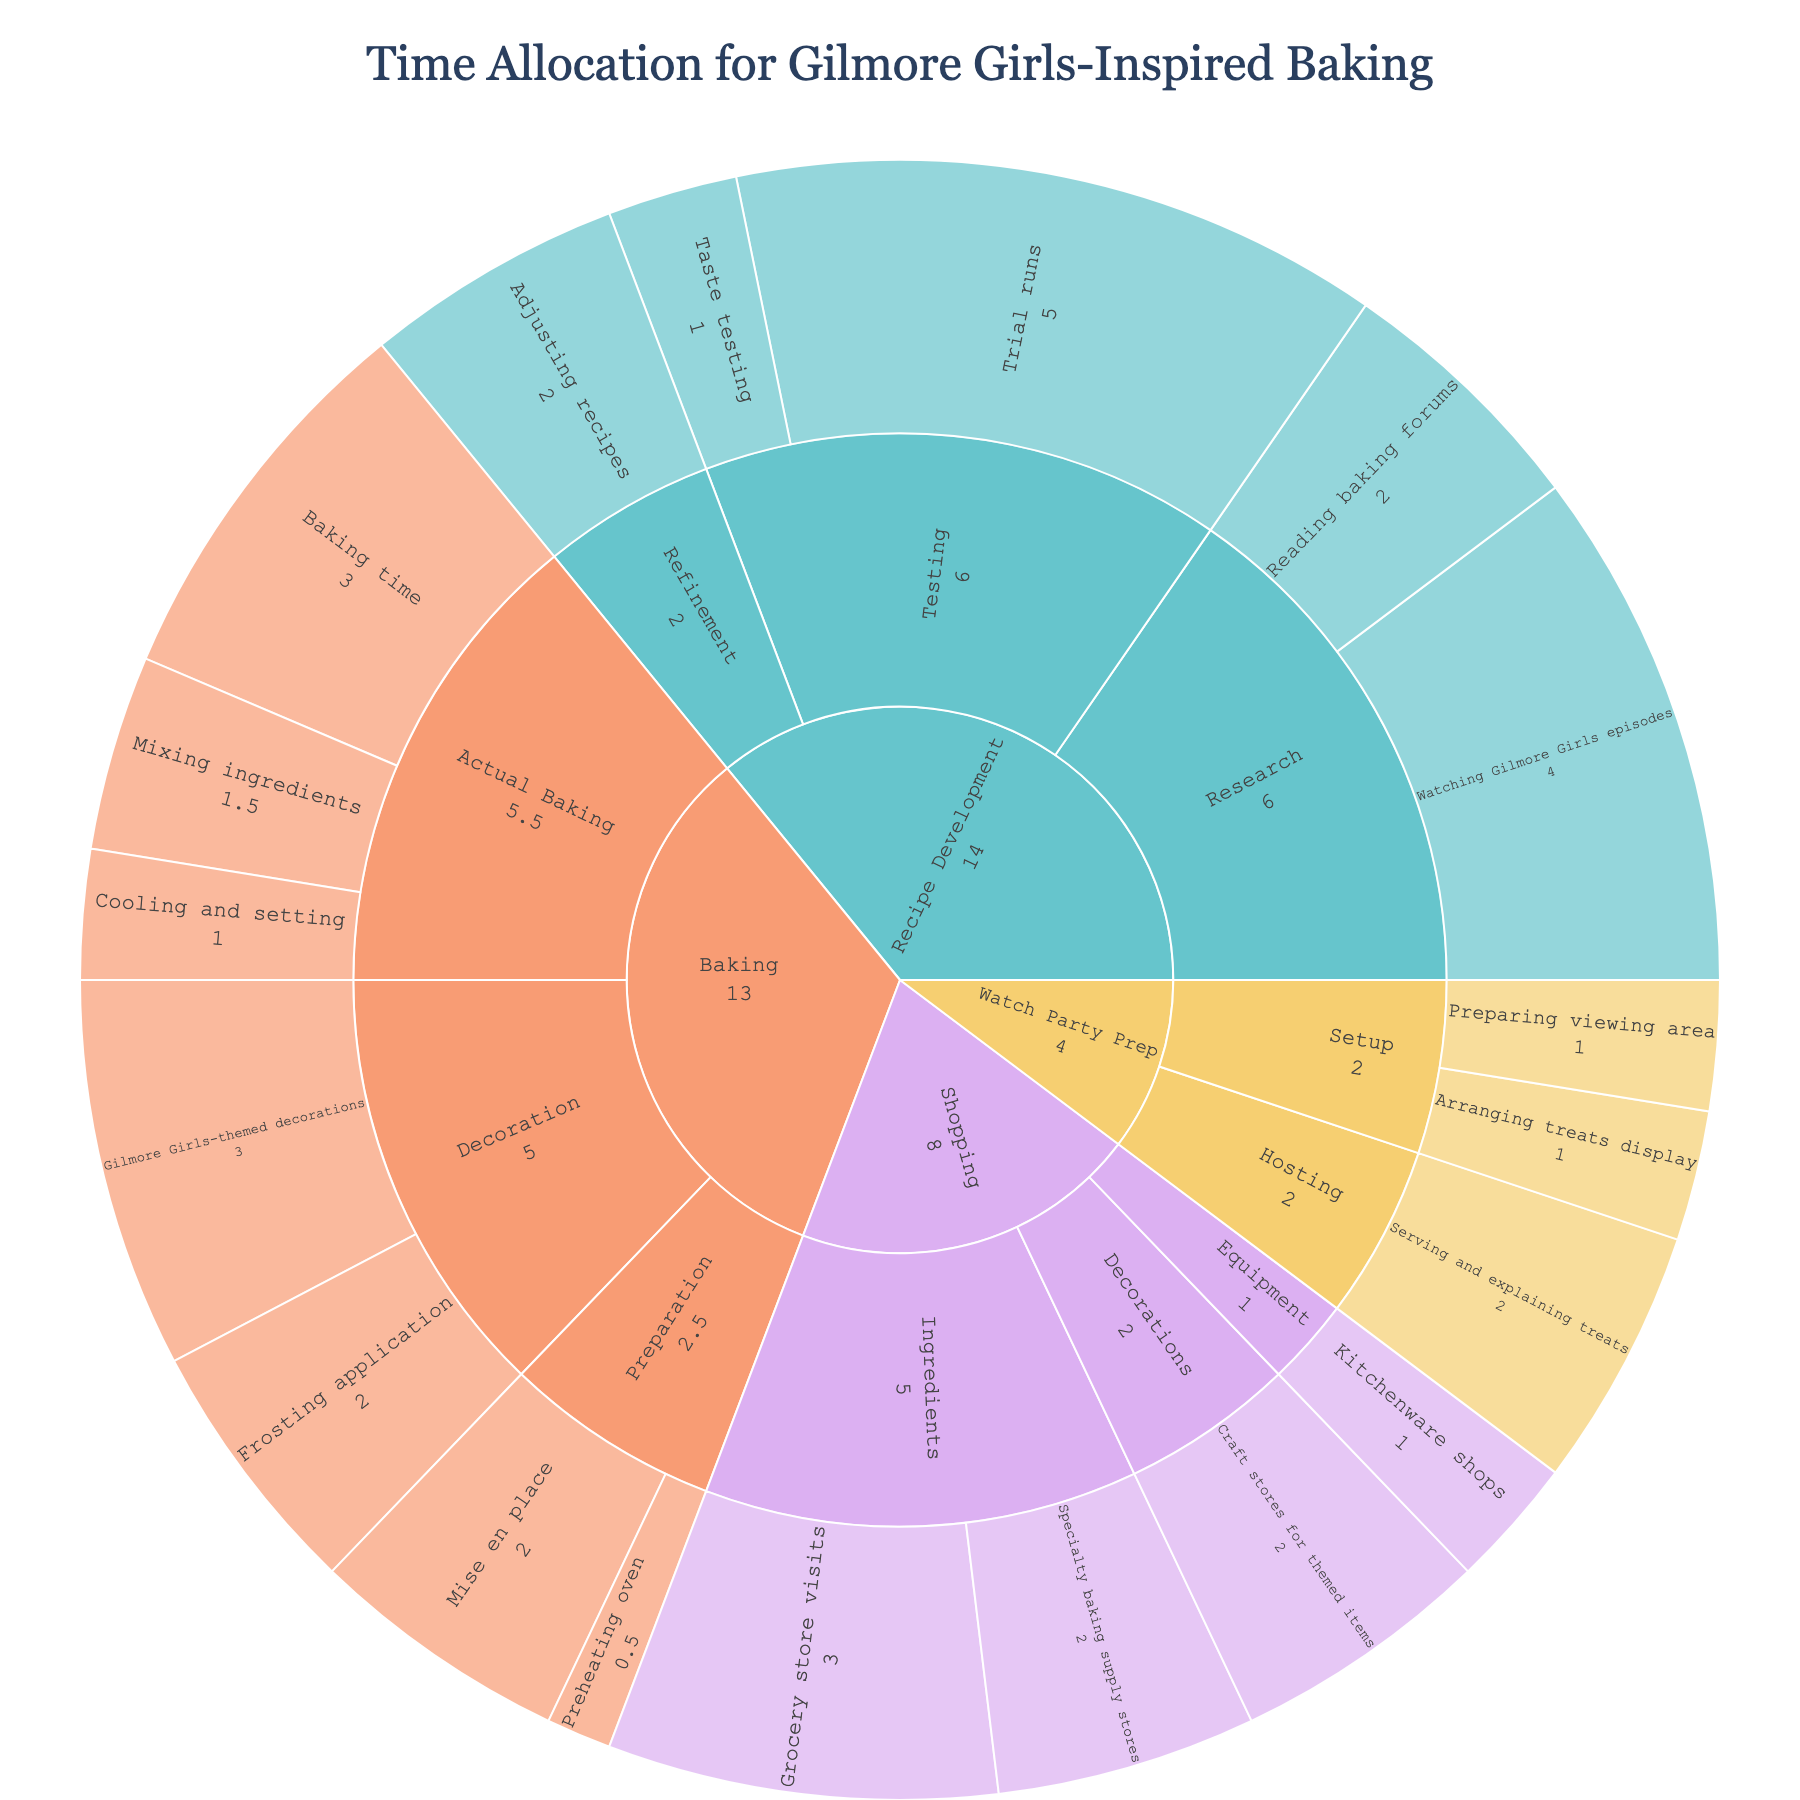What is the total time allocated for Recipe Development? To find the total time for Recipe Development, sum the hours for all activities under the Recipe Development category: Watching Gilmore Girls episodes (4), Reading baking forums (2), Trial runs (5), Taste testing (1), and Adjusting recipes (2). The total is 4 + 2 + 5 + 1 + 2 = 14.
Answer: 14 Which activity has the highest time allocation in the Baking category? Within the Baking category, identify the subcategories and activities, then find the highest hours value. Baking time in the Baking category has 3 hours, which is higher than any other activity within the category.
Answer: Baking time How much more time is spent on watching Gilmore Girls episodes compared to reading baking forums? Time spent on watching Gilmore Girls episodes is 4 hours and reading baking forums is 2 hours. The difference is 4 - 2 = 2 hours.
Answer: 2 Is the total time spent on Shopping activities more or less than the time spent on Recipe Development activities? Sum the hours for all activities in the Shopping category: Grocery store visits (3), Specialty baking supply stores (2), Kitchenware shops (1), and Craft stores for themed items (2). The total is 3 + 2 + 1 + 2 = 8. Compare this with the total time for Recipe Development, which is 14 hours. 8 is less than 14.
Answer: Less What percentage of the total baking time is spent on decoration activities? First, find the total hours spent on all baking activities: Preparation (2.5), Actual Baking (5.5), and Decoration (5). The total is 2.5 + 5.5 + 5 = 13. Decoration activities account for 5 hours, so the percentage is (5 / 13) * 100 ≈ 38.46%.
Answer: 38.46% How much time is spent on Watch Party Prep activities? Sum the hours spent on all Watch Party Prep activities: Arranging treats display (1), Preparing viewing area (1), and Serving and explaining treats (2). The total is 1 + 1 + 2 = 4 hours.
Answer: 4 Which category has the least amount of total time spent? By summing the hours for each category: Baking (13), Recipe Development (14), Shopping (8), and Watch Party Prep (4), it is clear that Watch Party Prep has the least time allocated with 4 hours.
Answer: Watch Party Prep How does the time spent on Trial runs compare to the time spent in Grocery store visits and Specialty baking supply stores combined? Time spent on Trial runs is 5 hours. The combined time for Grocery store visits (3) and Specialty baking supply stores (2) is 3 + 2 = 5 hours. Therefore, both are equal.
Answer: Equal 